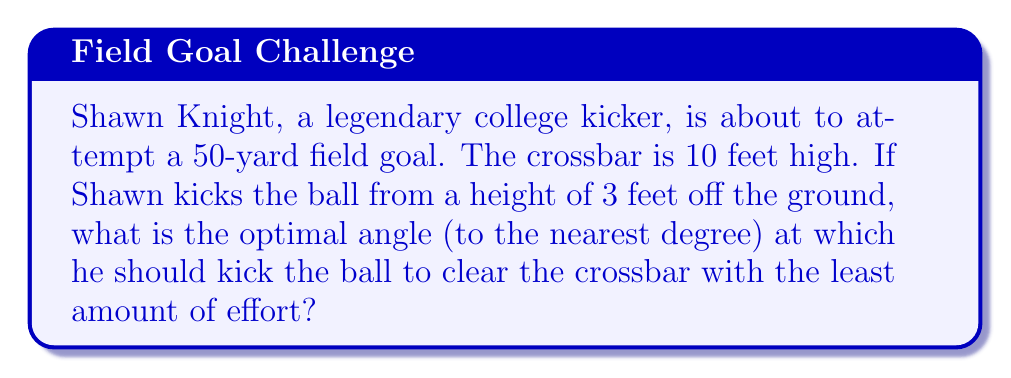Teach me how to tackle this problem. Let's approach this step-by-step using trigonometry:

1) First, let's visualize the problem:

[asy]
import geometry;

unitsize(4cm);

pair A = (0,0);
pair B = (5,0);
pair C = (5,0.7);
pair D = (0,0.3);

draw(A--B--C--D--A);
draw(D--(5,0.3),dashed);

label("Ground", (2.5,-0.1), S);
label("50 yards", (2.5,-0.2), S);
label("10 ft", (5.1,0.35), E);
label("3 ft", (-0.1,0.15), W);
label("θ", (0.2,0.4), NE);

dot("A", A, SW);
dot("B", B, SE);
dot("C", C, NE);
dot("D", D, NW);
[/asy]

2) We need to find the angle θ that minimizes the path of the ball.

3) The horizontal distance is 50 yards = 150 feet.

4) The vertical distance the ball needs to travel is 10 feet - 3 feet = 7 feet.

5) We can use the tangent function to relate these distances:

   $$\tan(\theta) = \frac{\text{opposite}}{\text{adjacent}} = \frac{7}{150}$$

6) To find θ, we take the inverse tangent (arctan or tan^(-1)):

   $$\theta = \tan^{-1}(\frac{7}{150})$$

7) Using a calculator:

   $$\theta \approx 2.67^\circ$$

8) Rounding to the nearest degree:

   $$\theta \approx 3^\circ$$

This angle will allow Shawn to clear the crossbar with the least amount of effort.
Answer: $3^\circ$ 